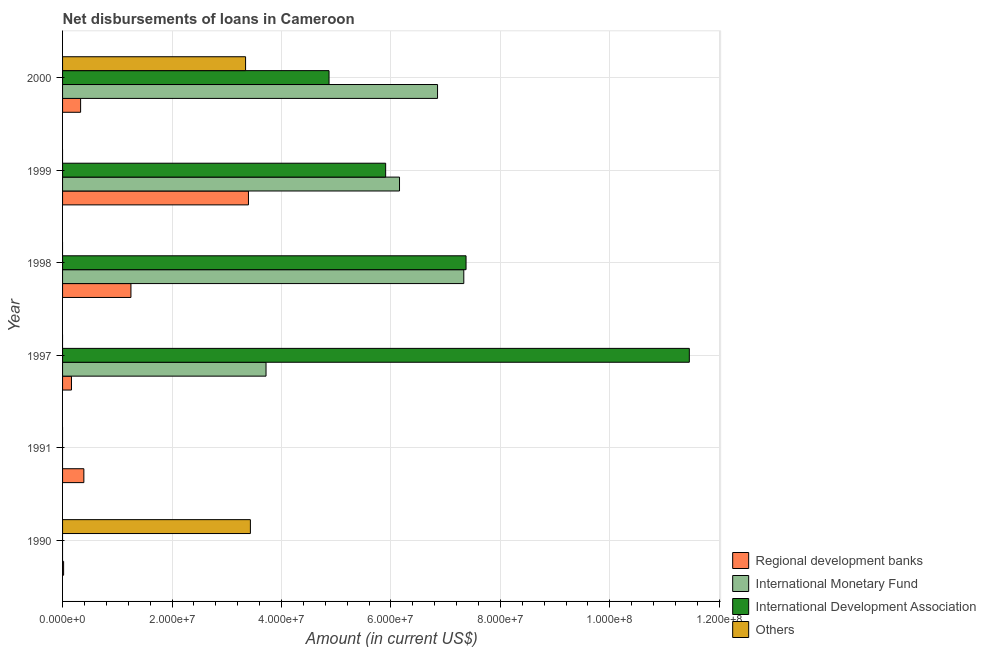How many different coloured bars are there?
Provide a short and direct response. 4. How many bars are there on the 3rd tick from the top?
Ensure brevity in your answer.  3. How many bars are there on the 3rd tick from the bottom?
Offer a very short reply. 3. What is the amount of loan disimbursed by regional development banks in 1999?
Give a very brief answer. 3.40e+07. Across all years, what is the maximum amount of loan disimbursed by international development association?
Ensure brevity in your answer.  1.15e+08. Across all years, what is the minimum amount of loan disimbursed by other organisations?
Keep it short and to the point. 0. In which year was the amount of loan disimbursed by international development association maximum?
Provide a succinct answer. 1997. What is the total amount of loan disimbursed by international monetary fund in the graph?
Your response must be concise. 2.41e+08. What is the difference between the amount of loan disimbursed by regional development banks in 1991 and that in 1999?
Ensure brevity in your answer.  -3.01e+07. What is the difference between the amount of loan disimbursed by international development association in 1999 and the amount of loan disimbursed by international monetary fund in 1998?
Your answer should be compact. -1.43e+07. What is the average amount of loan disimbursed by international monetary fund per year?
Your answer should be compact. 4.01e+07. In the year 1999, what is the difference between the amount of loan disimbursed by regional development banks and amount of loan disimbursed by international monetary fund?
Provide a succinct answer. -2.76e+07. In how many years, is the amount of loan disimbursed by international monetary fund greater than 32000000 US$?
Give a very brief answer. 4. What is the ratio of the amount of loan disimbursed by international monetary fund in 1999 to that in 2000?
Your answer should be very brief. 0.9. Is the difference between the amount of loan disimbursed by international development association in 1998 and 2000 greater than the difference between the amount of loan disimbursed by regional development banks in 1998 and 2000?
Your response must be concise. Yes. What is the difference between the highest and the second highest amount of loan disimbursed by international development association?
Keep it short and to the point. 4.08e+07. What is the difference between the highest and the lowest amount of loan disimbursed by international development association?
Provide a short and direct response. 1.15e+08. Is it the case that in every year, the sum of the amount of loan disimbursed by regional development banks and amount of loan disimbursed by international monetary fund is greater than the amount of loan disimbursed by international development association?
Offer a terse response. No. How many bars are there?
Your answer should be very brief. 16. Are all the bars in the graph horizontal?
Offer a terse response. Yes. What is the difference between two consecutive major ticks on the X-axis?
Ensure brevity in your answer.  2.00e+07. How are the legend labels stacked?
Your response must be concise. Vertical. What is the title of the graph?
Your response must be concise. Net disbursements of loans in Cameroon. What is the label or title of the X-axis?
Provide a succinct answer. Amount (in current US$). What is the label or title of the Y-axis?
Keep it short and to the point. Year. What is the Amount (in current US$) of Regional development banks in 1990?
Provide a succinct answer. 1.91e+05. What is the Amount (in current US$) in International Development Association in 1990?
Keep it short and to the point. 0. What is the Amount (in current US$) of Others in 1990?
Make the answer very short. 3.43e+07. What is the Amount (in current US$) in Regional development banks in 1991?
Give a very brief answer. 3.89e+06. What is the Amount (in current US$) of International Development Association in 1991?
Make the answer very short. 0. What is the Amount (in current US$) of Regional development banks in 1997?
Provide a succinct answer. 1.63e+06. What is the Amount (in current US$) in International Monetary Fund in 1997?
Offer a very short reply. 3.72e+07. What is the Amount (in current US$) of International Development Association in 1997?
Keep it short and to the point. 1.15e+08. What is the Amount (in current US$) of Others in 1997?
Provide a short and direct response. 0. What is the Amount (in current US$) in Regional development banks in 1998?
Keep it short and to the point. 1.25e+07. What is the Amount (in current US$) in International Monetary Fund in 1998?
Ensure brevity in your answer.  7.33e+07. What is the Amount (in current US$) of International Development Association in 1998?
Your response must be concise. 7.37e+07. What is the Amount (in current US$) of Regional development banks in 1999?
Offer a terse response. 3.40e+07. What is the Amount (in current US$) in International Monetary Fund in 1999?
Ensure brevity in your answer.  6.16e+07. What is the Amount (in current US$) in International Development Association in 1999?
Offer a terse response. 5.90e+07. What is the Amount (in current US$) of Others in 1999?
Make the answer very short. 0. What is the Amount (in current US$) of Regional development banks in 2000?
Offer a very short reply. 3.30e+06. What is the Amount (in current US$) in International Monetary Fund in 2000?
Make the answer very short. 6.85e+07. What is the Amount (in current US$) of International Development Association in 2000?
Your answer should be compact. 4.87e+07. What is the Amount (in current US$) in Others in 2000?
Your answer should be very brief. 3.34e+07. Across all years, what is the maximum Amount (in current US$) in Regional development banks?
Ensure brevity in your answer.  3.40e+07. Across all years, what is the maximum Amount (in current US$) in International Monetary Fund?
Give a very brief answer. 7.33e+07. Across all years, what is the maximum Amount (in current US$) in International Development Association?
Ensure brevity in your answer.  1.15e+08. Across all years, what is the maximum Amount (in current US$) of Others?
Your response must be concise. 3.43e+07. Across all years, what is the minimum Amount (in current US$) in Regional development banks?
Your answer should be compact. 1.91e+05. Across all years, what is the minimum Amount (in current US$) of International Development Association?
Offer a very short reply. 0. What is the total Amount (in current US$) in Regional development banks in the graph?
Ensure brevity in your answer.  5.55e+07. What is the total Amount (in current US$) in International Monetary Fund in the graph?
Ensure brevity in your answer.  2.41e+08. What is the total Amount (in current US$) in International Development Association in the graph?
Provide a succinct answer. 2.96e+08. What is the total Amount (in current US$) in Others in the graph?
Your answer should be compact. 6.78e+07. What is the difference between the Amount (in current US$) in Regional development banks in 1990 and that in 1991?
Provide a short and direct response. -3.70e+06. What is the difference between the Amount (in current US$) in Regional development banks in 1990 and that in 1997?
Provide a succinct answer. -1.44e+06. What is the difference between the Amount (in current US$) in Regional development banks in 1990 and that in 1998?
Ensure brevity in your answer.  -1.23e+07. What is the difference between the Amount (in current US$) of Regional development banks in 1990 and that in 1999?
Your answer should be very brief. -3.38e+07. What is the difference between the Amount (in current US$) in Regional development banks in 1990 and that in 2000?
Ensure brevity in your answer.  -3.10e+06. What is the difference between the Amount (in current US$) in Others in 1990 and that in 2000?
Provide a succinct answer. 8.81e+05. What is the difference between the Amount (in current US$) in Regional development banks in 1991 and that in 1997?
Provide a short and direct response. 2.26e+06. What is the difference between the Amount (in current US$) in Regional development banks in 1991 and that in 1998?
Provide a succinct answer. -8.60e+06. What is the difference between the Amount (in current US$) in Regional development banks in 1991 and that in 1999?
Keep it short and to the point. -3.01e+07. What is the difference between the Amount (in current US$) in Regional development banks in 1991 and that in 2000?
Your response must be concise. 5.94e+05. What is the difference between the Amount (in current US$) in Regional development banks in 1997 and that in 1998?
Your response must be concise. -1.09e+07. What is the difference between the Amount (in current US$) in International Monetary Fund in 1997 and that in 1998?
Ensure brevity in your answer.  -3.61e+07. What is the difference between the Amount (in current US$) of International Development Association in 1997 and that in 1998?
Ensure brevity in your answer.  4.08e+07. What is the difference between the Amount (in current US$) of Regional development banks in 1997 and that in 1999?
Ensure brevity in your answer.  -3.23e+07. What is the difference between the Amount (in current US$) of International Monetary Fund in 1997 and that in 1999?
Offer a very short reply. -2.44e+07. What is the difference between the Amount (in current US$) in International Development Association in 1997 and that in 1999?
Keep it short and to the point. 5.55e+07. What is the difference between the Amount (in current US$) of Regional development banks in 1997 and that in 2000?
Make the answer very short. -1.67e+06. What is the difference between the Amount (in current US$) of International Monetary Fund in 1997 and that in 2000?
Keep it short and to the point. -3.13e+07. What is the difference between the Amount (in current US$) in International Development Association in 1997 and that in 2000?
Provide a succinct answer. 6.58e+07. What is the difference between the Amount (in current US$) of Regional development banks in 1998 and that in 1999?
Provide a succinct answer. -2.15e+07. What is the difference between the Amount (in current US$) in International Monetary Fund in 1998 and that in 1999?
Your response must be concise. 1.17e+07. What is the difference between the Amount (in current US$) of International Development Association in 1998 and that in 1999?
Make the answer very short. 1.47e+07. What is the difference between the Amount (in current US$) of Regional development banks in 1998 and that in 2000?
Your answer should be compact. 9.20e+06. What is the difference between the Amount (in current US$) of International Monetary Fund in 1998 and that in 2000?
Your response must be concise. 4.80e+06. What is the difference between the Amount (in current US$) in International Development Association in 1998 and that in 2000?
Your answer should be compact. 2.50e+07. What is the difference between the Amount (in current US$) of Regional development banks in 1999 and that in 2000?
Your response must be concise. 3.07e+07. What is the difference between the Amount (in current US$) of International Monetary Fund in 1999 and that in 2000?
Your answer should be compact. -6.95e+06. What is the difference between the Amount (in current US$) of International Development Association in 1999 and that in 2000?
Provide a short and direct response. 1.03e+07. What is the difference between the Amount (in current US$) of Regional development banks in 1990 and the Amount (in current US$) of International Monetary Fund in 1997?
Your answer should be very brief. -3.70e+07. What is the difference between the Amount (in current US$) in Regional development banks in 1990 and the Amount (in current US$) in International Development Association in 1997?
Offer a very short reply. -1.14e+08. What is the difference between the Amount (in current US$) of Regional development banks in 1990 and the Amount (in current US$) of International Monetary Fund in 1998?
Offer a terse response. -7.31e+07. What is the difference between the Amount (in current US$) in Regional development banks in 1990 and the Amount (in current US$) in International Development Association in 1998?
Ensure brevity in your answer.  -7.35e+07. What is the difference between the Amount (in current US$) in Regional development banks in 1990 and the Amount (in current US$) in International Monetary Fund in 1999?
Give a very brief answer. -6.14e+07. What is the difference between the Amount (in current US$) of Regional development banks in 1990 and the Amount (in current US$) of International Development Association in 1999?
Your answer should be compact. -5.88e+07. What is the difference between the Amount (in current US$) of Regional development banks in 1990 and the Amount (in current US$) of International Monetary Fund in 2000?
Provide a succinct answer. -6.83e+07. What is the difference between the Amount (in current US$) of Regional development banks in 1990 and the Amount (in current US$) of International Development Association in 2000?
Keep it short and to the point. -4.85e+07. What is the difference between the Amount (in current US$) in Regional development banks in 1990 and the Amount (in current US$) in Others in 2000?
Your answer should be compact. -3.33e+07. What is the difference between the Amount (in current US$) in Regional development banks in 1991 and the Amount (in current US$) in International Monetary Fund in 1997?
Give a very brief answer. -3.33e+07. What is the difference between the Amount (in current US$) of Regional development banks in 1991 and the Amount (in current US$) of International Development Association in 1997?
Offer a terse response. -1.11e+08. What is the difference between the Amount (in current US$) in Regional development banks in 1991 and the Amount (in current US$) in International Monetary Fund in 1998?
Ensure brevity in your answer.  -6.94e+07. What is the difference between the Amount (in current US$) of Regional development banks in 1991 and the Amount (in current US$) of International Development Association in 1998?
Your answer should be very brief. -6.98e+07. What is the difference between the Amount (in current US$) in Regional development banks in 1991 and the Amount (in current US$) in International Monetary Fund in 1999?
Your response must be concise. -5.77e+07. What is the difference between the Amount (in current US$) in Regional development banks in 1991 and the Amount (in current US$) in International Development Association in 1999?
Your response must be concise. -5.52e+07. What is the difference between the Amount (in current US$) in Regional development banks in 1991 and the Amount (in current US$) in International Monetary Fund in 2000?
Ensure brevity in your answer.  -6.46e+07. What is the difference between the Amount (in current US$) of Regional development banks in 1991 and the Amount (in current US$) of International Development Association in 2000?
Keep it short and to the point. -4.48e+07. What is the difference between the Amount (in current US$) in Regional development banks in 1991 and the Amount (in current US$) in Others in 2000?
Ensure brevity in your answer.  -2.96e+07. What is the difference between the Amount (in current US$) of Regional development banks in 1997 and the Amount (in current US$) of International Monetary Fund in 1998?
Provide a succinct answer. -7.17e+07. What is the difference between the Amount (in current US$) of Regional development banks in 1997 and the Amount (in current US$) of International Development Association in 1998?
Your answer should be compact. -7.21e+07. What is the difference between the Amount (in current US$) in International Monetary Fund in 1997 and the Amount (in current US$) in International Development Association in 1998?
Give a very brief answer. -3.65e+07. What is the difference between the Amount (in current US$) of Regional development banks in 1997 and the Amount (in current US$) of International Monetary Fund in 1999?
Provide a short and direct response. -5.99e+07. What is the difference between the Amount (in current US$) of Regional development banks in 1997 and the Amount (in current US$) of International Development Association in 1999?
Offer a terse response. -5.74e+07. What is the difference between the Amount (in current US$) in International Monetary Fund in 1997 and the Amount (in current US$) in International Development Association in 1999?
Offer a terse response. -2.19e+07. What is the difference between the Amount (in current US$) of Regional development banks in 1997 and the Amount (in current US$) of International Monetary Fund in 2000?
Ensure brevity in your answer.  -6.69e+07. What is the difference between the Amount (in current US$) of Regional development banks in 1997 and the Amount (in current US$) of International Development Association in 2000?
Provide a succinct answer. -4.71e+07. What is the difference between the Amount (in current US$) in Regional development banks in 1997 and the Amount (in current US$) in Others in 2000?
Your answer should be compact. -3.18e+07. What is the difference between the Amount (in current US$) in International Monetary Fund in 1997 and the Amount (in current US$) in International Development Association in 2000?
Offer a terse response. -1.15e+07. What is the difference between the Amount (in current US$) of International Monetary Fund in 1997 and the Amount (in current US$) of Others in 2000?
Offer a terse response. 3.74e+06. What is the difference between the Amount (in current US$) in International Development Association in 1997 and the Amount (in current US$) in Others in 2000?
Your answer should be compact. 8.11e+07. What is the difference between the Amount (in current US$) in Regional development banks in 1998 and the Amount (in current US$) in International Monetary Fund in 1999?
Provide a succinct answer. -4.91e+07. What is the difference between the Amount (in current US$) in Regional development banks in 1998 and the Amount (in current US$) in International Development Association in 1999?
Offer a terse response. -4.65e+07. What is the difference between the Amount (in current US$) in International Monetary Fund in 1998 and the Amount (in current US$) in International Development Association in 1999?
Your answer should be very brief. 1.43e+07. What is the difference between the Amount (in current US$) in Regional development banks in 1998 and the Amount (in current US$) in International Monetary Fund in 2000?
Give a very brief answer. -5.60e+07. What is the difference between the Amount (in current US$) in Regional development banks in 1998 and the Amount (in current US$) in International Development Association in 2000?
Give a very brief answer. -3.62e+07. What is the difference between the Amount (in current US$) in Regional development banks in 1998 and the Amount (in current US$) in Others in 2000?
Make the answer very short. -2.09e+07. What is the difference between the Amount (in current US$) of International Monetary Fund in 1998 and the Amount (in current US$) of International Development Association in 2000?
Your response must be concise. 2.46e+07. What is the difference between the Amount (in current US$) of International Monetary Fund in 1998 and the Amount (in current US$) of Others in 2000?
Ensure brevity in your answer.  3.99e+07. What is the difference between the Amount (in current US$) in International Development Association in 1998 and the Amount (in current US$) in Others in 2000?
Your response must be concise. 4.03e+07. What is the difference between the Amount (in current US$) of Regional development banks in 1999 and the Amount (in current US$) of International Monetary Fund in 2000?
Keep it short and to the point. -3.46e+07. What is the difference between the Amount (in current US$) of Regional development banks in 1999 and the Amount (in current US$) of International Development Association in 2000?
Offer a very short reply. -1.47e+07. What is the difference between the Amount (in current US$) in Regional development banks in 1999 and the Amount (in current US$) in Others in 2000?
Provide a succinct answer. 5.25e+05. What is the difference between the Amount (in current US$) in International Monetary Fund in 1999 and the Amount (in current US$) in International Development Association in 2000?
Offer a terse response. 1.29e+07. What is the difference between the Amount (in current US$) of International Monetary Fund in 1999 and the Amount (in current US$) of Others in 2000?
Give a very brief answer. 2.81e+07. What is the difference between the Amount (in current US$) in International Development Association in 1999 and the Amount (in current US$) in Others in 2000?
Your response must be concise. 2.56e+07. What is the average Amount (in current US$) of Regional development banks per year?
Provide a short and direct response. 9.24e+06. What is the average Amount (in current US$) of International Monetary Fund per year?
Ensure brevity in your answer.  4.01e+07. What is the average Amount (in current US$) of International Development Association per year?
Offer a very short reply. 4.93e+07. What is the average Amount (in current US$) of Others per year?
Offer a terse response. 1.13e+07. In the year 1990, what is the difference between the Amount (in current US$) in Regional development banks and Amount (in current US$) in Others?
Your response must be concise. -3.41e+07. In the year 1997, what is the difference between the Amount (in current US$) of Regional development banks and Amount (in current US$) of International Monetary Fund?
Give a very brief answer. -3.56e+07. In the year 1997, what is the difference between the Amount (in current US$) of Regional development banks and Amount (in current US$) of International Development Association?
Your answer should be very brief. -1.13e+08. In the year 1997, what is the difference between the Amount (in current US$) in International Monetary Fund and Amount (in current US$) in International Development Association?
Ensure brevity in your answer.  -7.74e+07. In the year 1998, what is the difference between the Amount (in current US$) of Regional development banks and Amount (in current US$) of International Monetary Fund?
Offer a terse response. -6.08e+07. In the year 1998, what is the difference between the Amount (in current US$) in Regional development banks and Amount (in current US$) in International Development Association?
Your answer should be very brief. -6.12e+07. In the year 1998, what is the difference between the Amount (in current US$) in International Monetary Fund and Amount (in current US$) in International Development Association?
Offer a terse response. -4.10e+05. In the year 1999, what is the difference between the Amount (in current US$) of Regional development banks and Amount (in current US$) of International Monetary Fund?
Offer a terse response. -2.76e+07. In the year 1999, what is the difference between the Amount (in current US$) of Regional development banks and Amount (in current US$) of International Development Association?
Your response must be concise. -2.51e+07. In the year 1999, what is the difference between the Amount (in current US$) of International Monetary Fund and Amount (in current US$) of International Development Association?
Offer a very short reply. 2.53e+06. In the year 2000, what is the difference between the Amount (in current US$) in Regional development banks and Amount (in current US$) in International Monetary Fund?
Make the answer very short. -6.52e+07. In the year 2000, what is the difference between the Amount (in current US$) of Regional development banks and Amount (in current US$) of International Development Association?
Ensure brevity in your answer.  -4.54e+07. In the year 2000, what is the difference between the Amount (in current US$) of Regional development banks and Amount (in current US$) of Others?
Offer a very short reply. -3.01e+07. In the year 2000, what is the difference between the Amount (in current US$) of International Monetary Fund and Amount (in current US$) of International Development Association?
Offer a very short reply. 1.98e+07. In the year 2000, what is the difference between the Amount (in current US$) in International Monetary Fund and Amount (in current US$) in Others?
Provide a short and direct response. 3.51e+07. In the year 2000, what is the difference between the Amount (in current US$) in International Development Association and Amount (in current US$) in Others?
Provide a succinct answer. 1.53e+07. What is the ratio of the Amount (in current US$) in Regional development banks in 1990 to that in 1991?
Keep it short and to the point. 0.05. What is the ratio of the Amount (in current US$) in Regional development banks in 1990 to that in 1997?
Ensure brevity in your answer.  0.12. What is the ratio of the Amount (in current US$) of Regional development banks in 1990 to that in 1998?
Offer a very short reply. 0.02. What is the ratio of the Amount (in current US$) of Regional development banks in 1990 to that in 1999?
Provide a short and direct response. 0.01. What is the ratio of the Amount (in current US$) of Regional development banks in 1990 to that in 2000?
Offer a terse response. 0.06. What is the ratio of the Amount (in current US$) in Others in 1990 to that in 2000?
Provide a succinct answer. 1.03. What is the ratio of the Amount (in current US$) of Regional development banks in 1991 to that in 1997?
Your answer should be very brief. 2.39. What is the ratio of the Amount (in current US$) of Regional development banks in 1991 to that in 1998?
Ensure brevity in your answer.  0.31. What is the ratio of the Amount (in current US$) in Regional development banks in 1991 to that in 1999?
Provide a succinct answer. 0.11. What is the ratio of the Amount (in current US$) in Regional development banks in 1991 to that in 2000?
Your answer should be very brief. 1.18. What is the ratio of the Amount (in current US$) in Regional development banks in 1997 to that in 1998?
Ensure brevity in your answer.  0.13. What is the ratio of the Amount (in current US$) of International Monetary Fund in 1997 to that in 1998?
Ensure brevity in your answer.  0.51. What is the ratio of the Amount (in current US$) in International Development Association in 1997 to that in 1998?
Offer a very short reply. 1.55. What is the ratio of the Amount (in current US$) of Regional development banks in 1997 to that in 1999?
Give a very brief answer. 0.05. What is the ratio of the Amount (in current US$) of International Monetary Fund in 1997 to that in 1999?
Offer a very short reply. 0.6. What is the ratio of the Amount (in current US$) of International Development Association in 1997 to that in 1999?
Offer a terse response. 1.94. What is the ratio of the Amount (in current US$) in Regional development banks in 1997 to that in 2000?
Make the answer very short. 0.49. What is the ratio of the Amount (in current US$) in International Monetary Fund in 1997 to that in 2000?
Offer a very short reply. 0.54. What is the ratio of the Amount (in current US$) in International Development Association in 1997 to that in 2000?
Your response must be concise. 2.35. What is the ratio of the Amount (in current US$) in Regional development banks in 1998 to that in 1999?
Keep it short and to the point. 0.37. What is the ratio of the Amount (in current US$) in International Monetary Fund in 1998 to that in 1999?
Give a very brief answer. 1.19. What is the ratio of the Amount (in current US$) of International Development Association in 1998 to that in 1999?
Provide a succinct answer. 1.25. What is the ratio of the Amount (in current US$) of Regional development banks in 1998 to that in 2000?
Provide a succinct answer. 3.79. What is the ratio of the Amount (in current US$) in International Monetary Fund in 1998 to that in 2000?
Your answer should be compact. 1.07. What is the ratio of the Amount (in current US$) in International Development Association in 1998 to that in 2000?
Give a very brief answer. 1.51. What is the ratio of the Amount (in current US$) in Regional development banks in 1999 to that in 2000?
Make the answer very short. 10.31. What is the ratio of the Amount (in current US$) of International Monetary Fund in 1999 to that in 2000?
Give a very brief answer. 0.9. What is the ratio of the Amount (in current US$) in International Development Association in 1999 to that in 2000?
Your response must be concise. 1.21. What is the difference between the highest and the second highest Amount (in current US$) of Regional development banks?
Your answer should be very brief. 2.15e+07. What is the difference between the highest and the second highest Amount (in current US$) in International Monetary Fund?
Offer a very short reply. 4.80e+06. What is the difference between the highest and the second highest Amount (in current US$) in International Development Association?
Ensure brevity in your answer.  4.08e+07. What is the difference between the highest and the lowest Amount (in current US$) in Regional development banks?
Provide a short and direct response. 3.38e+07. What is the difference between the highest and the lowest Amount (in current US$) of International Monetary Fund?
Offer a terse response. 7.33e+07. What is the difference between the highest and the lowest Amount (in current US$) of International Development Association?
Offer a very short reply. 1.15e+08. What is the difference between the highest and the lowest Amount (in current US$) of Others?
Offer a terse response. 3.43e+07. 